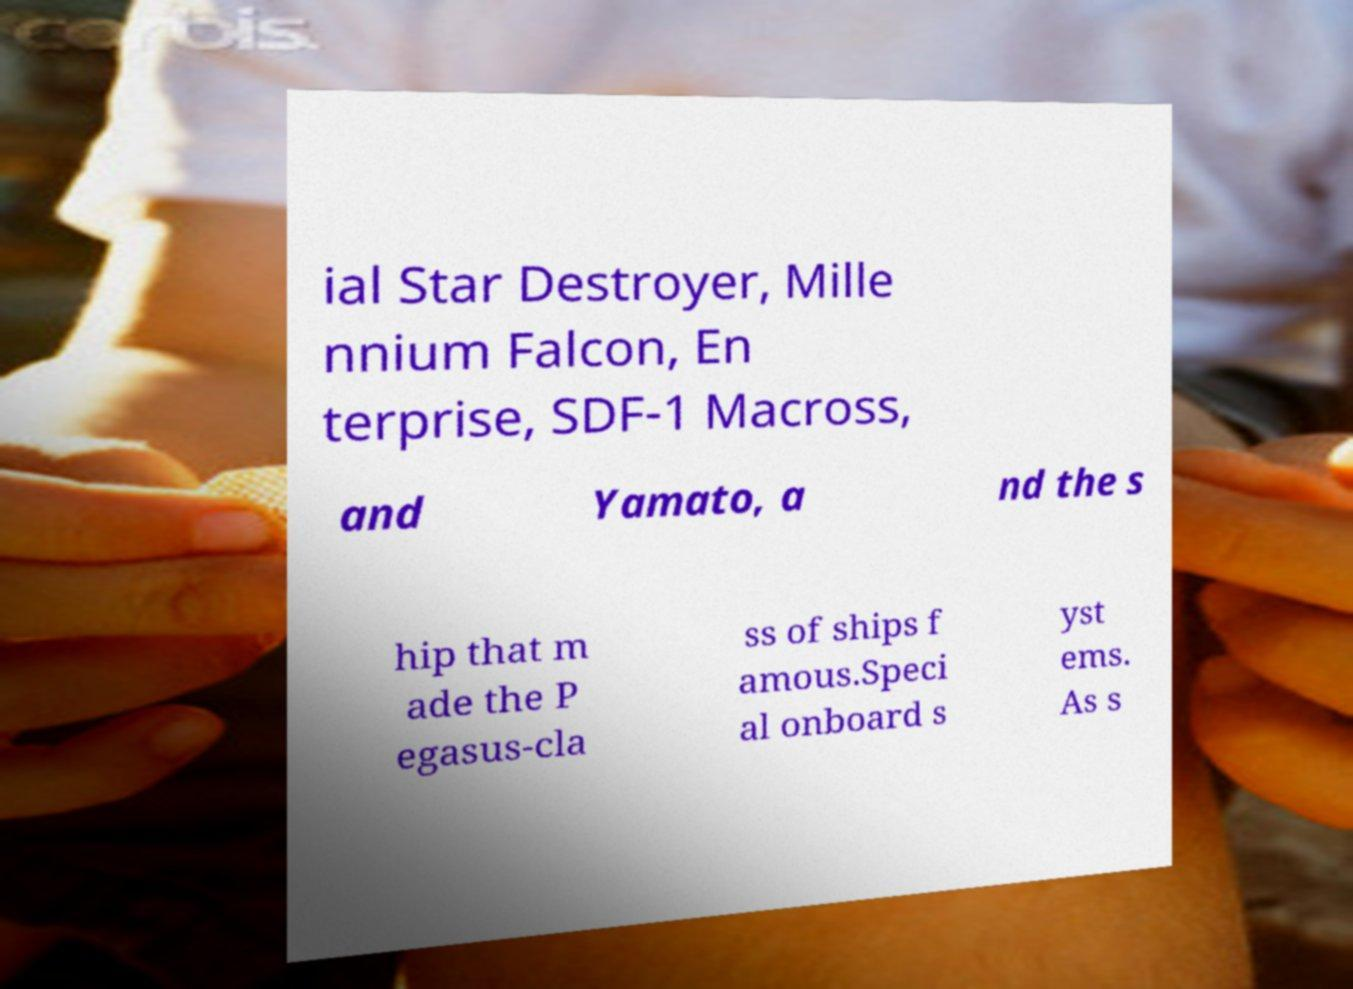Please identify and transcribe the text found in this image. ial Star Destroyer, Mille nnium Falcon, En terprise, SDF-1 Macross, and Yamato, a nd the s hip that m ade the P egasus-cla ss of ships f amous.Speci al onboard s yst ems. As s 